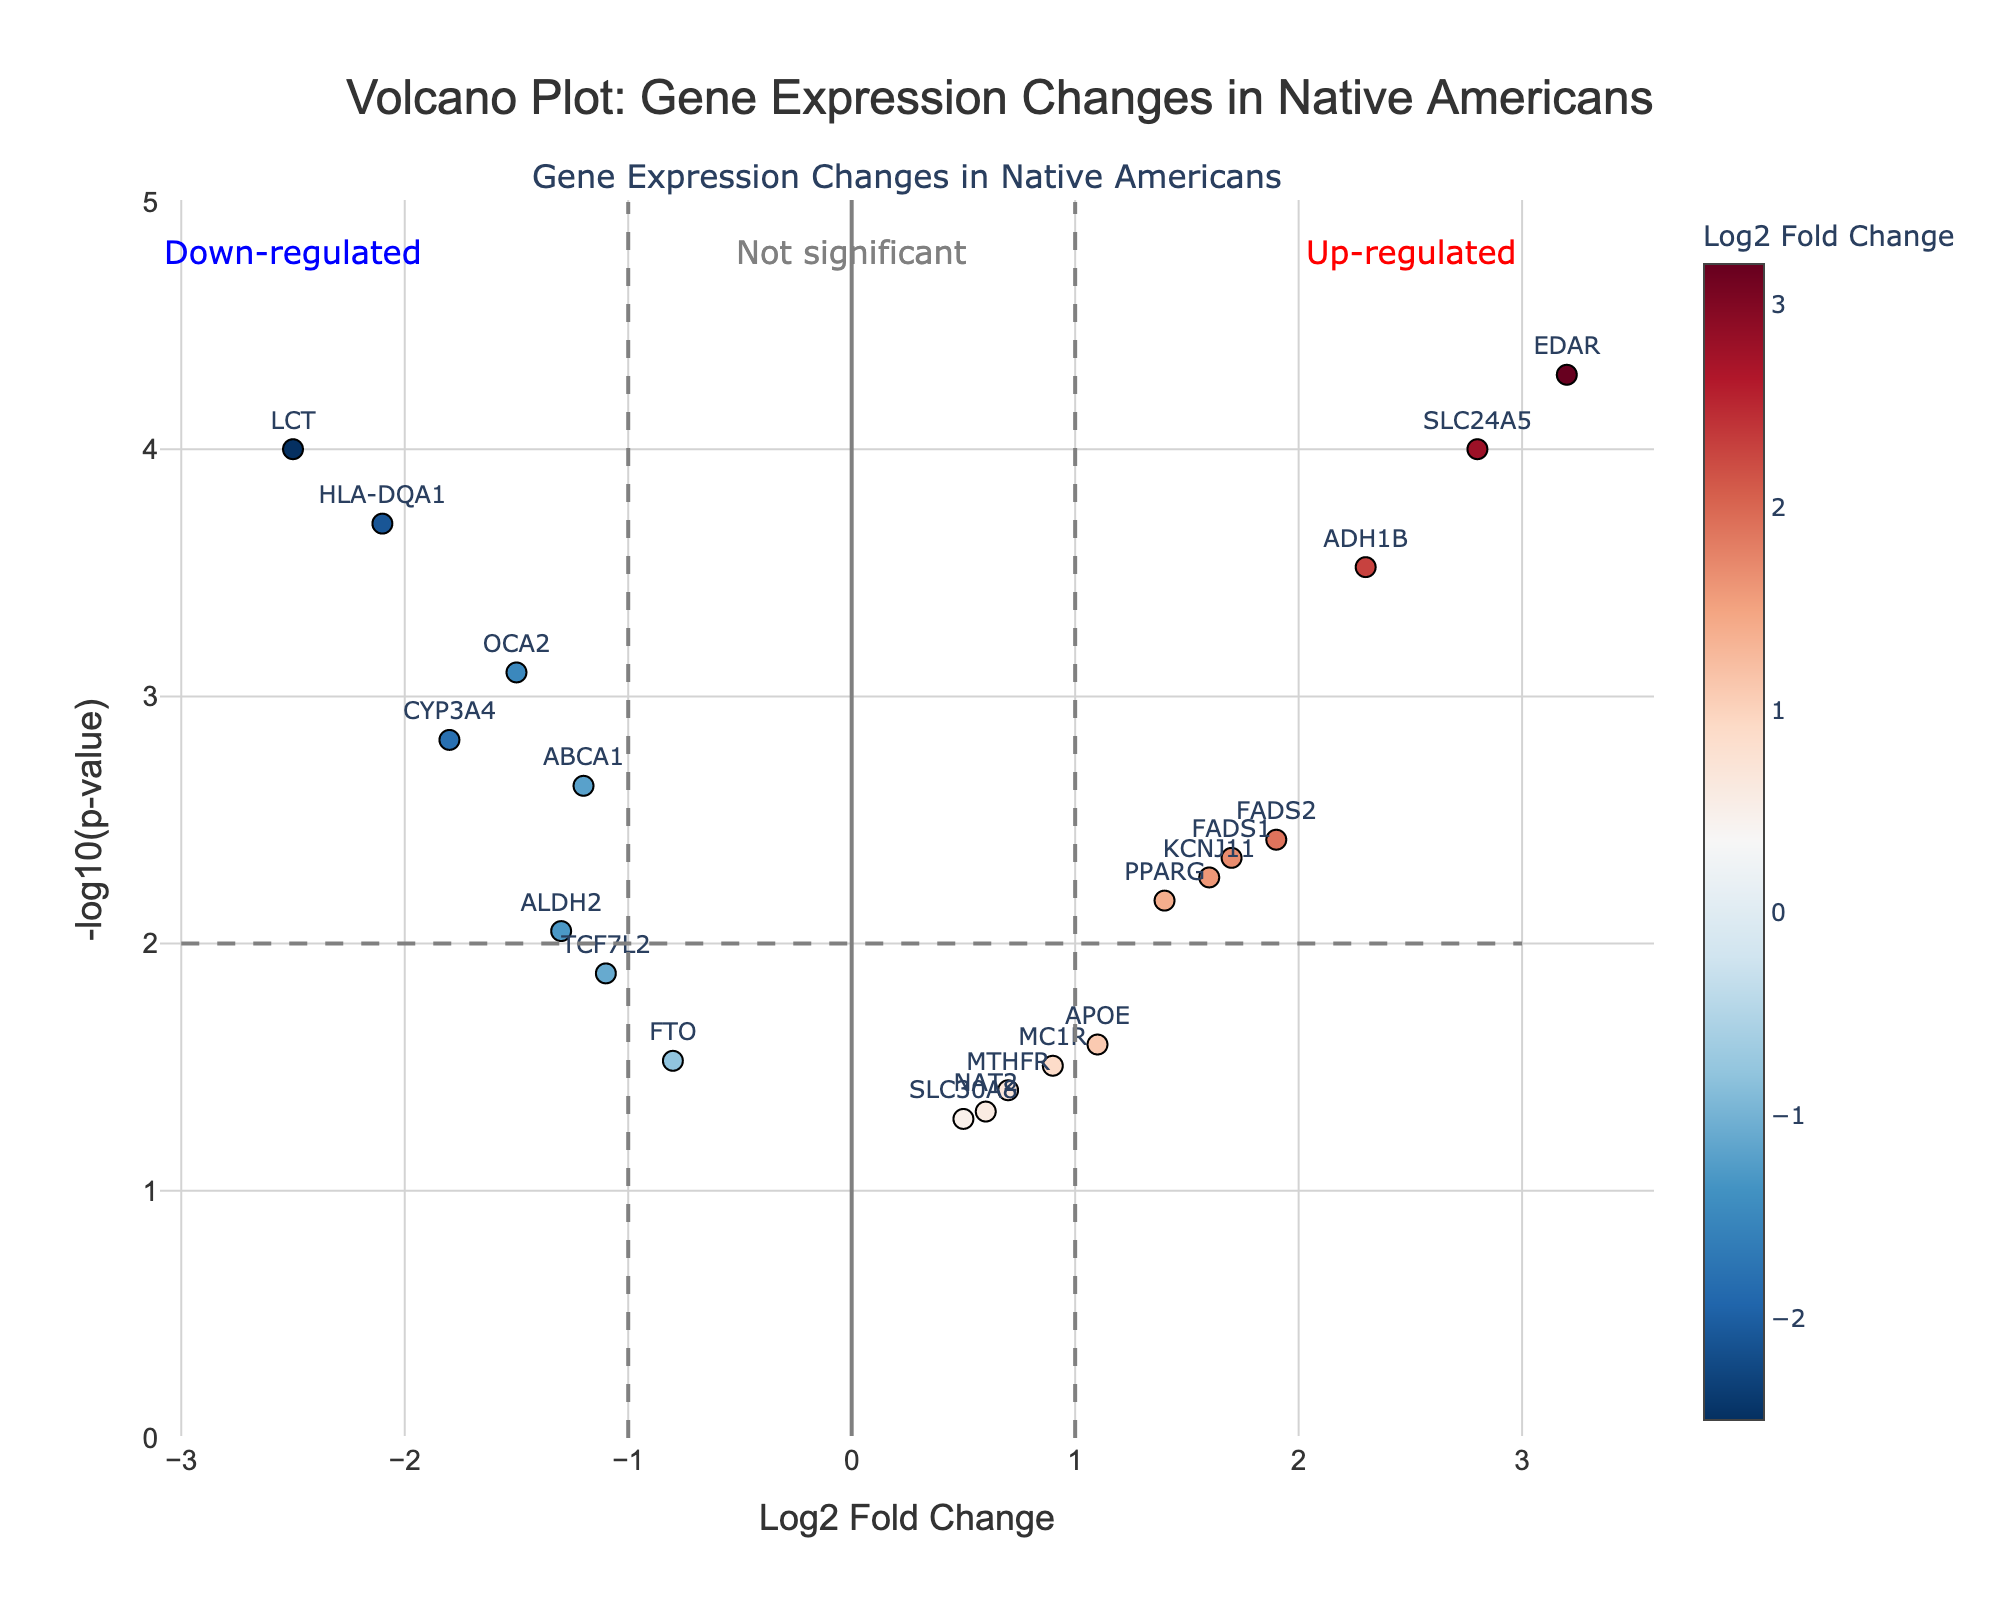Which gene has the highest Log2 Fold Change? Looking at the scatter plot, we see that EDAR has the highest Log2 Fold Change value at approximately 3.2.
Answer: EDAR Which gene shows the lowest p-value? The p-value plot (-log10(p-value)) is highest for EDAR, indicating it has the smallest p-value.
Answer: EDAR What is the title of the figure? The title is displayed at the top of the plot, which reads 'Volcano Plot: Gene Expression Changes in Native Americans'.
Answer: Volcano Plot: Gene Expression Changes in Native Americans Which gene is the most down-regulated? The most down-regulated gene has the lowest Log2 Fold Change value. LCT, with a Log2 Fold Change of approximately -2.5, is the most down-regulated.
Answer: LCT How many genes have a Log2 Fold Change greater than 1? By visually inspecting the scatter plot and counting the points to the right of the vertical line at Log2 Fold Change = 1, we find that 7 genes meet this criterion: SLC24A5, EDAR, ADH1B, FADS1, FADS2, KCNJ11, and PPARG.
Answer: 7 How many genes are not significantly differentially expressed? Non-significant genes are those below the horizontal -log10(p-value) threshold line of 2. Counting these points shows that 7 genes fall into this category: MC1R, NAT2, APOE, MTHFR, ALDH2, FTO, and SLC30A8.
Answer: 7 Which gene is up-regulated and has a p-value less than 0.001? An up-regulated gene has a positive Log2 Fold Change. Observing the points above the -log10(p-value) threshold line of 3 (indicating a p-value less than 0.001) and on the right side, EDAR, SLC24A5, and ADH1B qualify.
Answer: EDAR, SLC24A5, ADH1B What range of values does the Log2 Fold Change span in this plot? The Log2 Fold Change ranges from approximately -2.5 (LCT) to 3.2 (EDAR).
Answer: -2.5 to 3.2 Which gene is closest to having no change in expression? A gene with Log2 Fold Change close to 0 shows minimal expression change. Observing the plot, SLC30A8, with a Log2 Fold Change approximately equal to 0.5, is the closest.
Answer: SLC30A8 